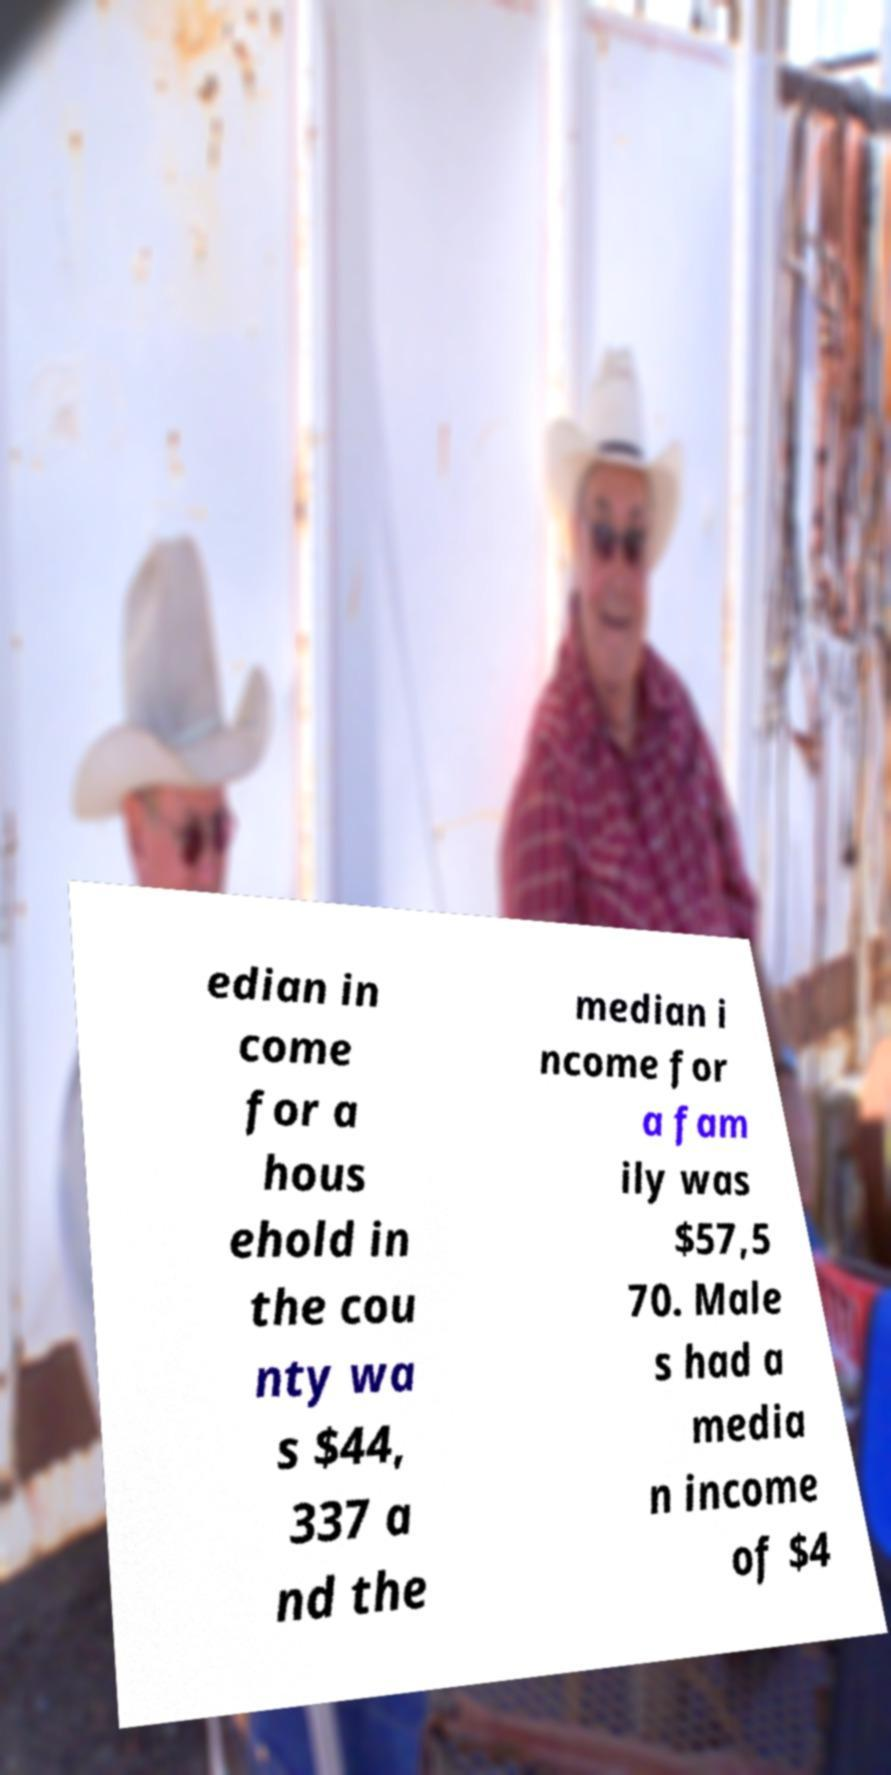Please read and relay the text visible in this image. What does it say? edian in come for a hous ehold in the cou nty wa s $44, 337 a nd the median i ncome for a fam ily was $57,5 70. Male s had a media n income of $4 